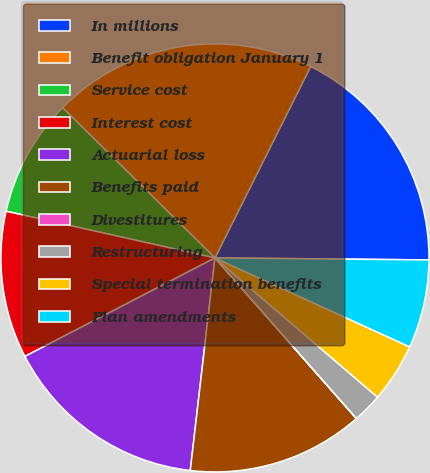Convert chart. <chart><loc_0><loc_0><loc_500><loc_500><pie_chart><fcel>In millions<fcel>Benefit obligation January 1<fcel>Service cost<fcel>Interest cost<fcel>Actuarial loss<fcel>Benefits paid<fcel>Divestitures<fcel>Restructuring<fcel>Special termination benefits<fcel>Plan amendments<nl><fcel>17.77%<fcel>19.99%<fcel>8.89%<fcel>11.11%<fcel>15.55%<fcel>13.33%<fcel>0.01%<fcel>2.23%<fcel>4.45%<fcel>6.67%<nl></chart> 